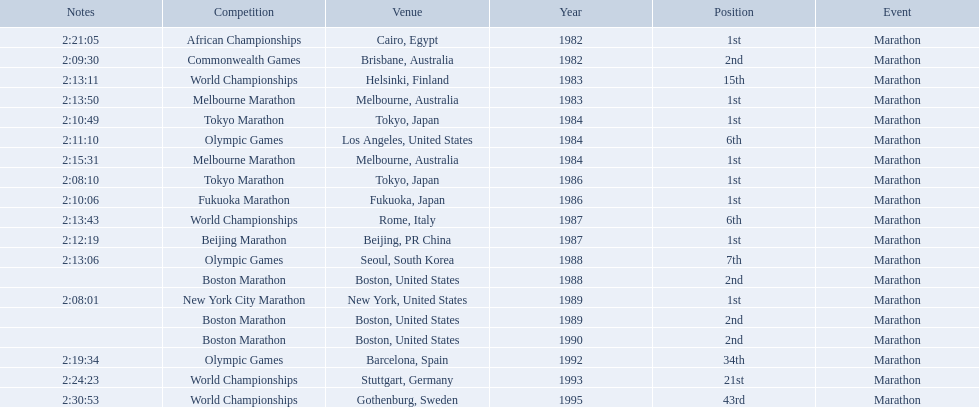What are all of the juma ikangaa competitions? African Championships, Commonwealth Games, World Championships, Melbourne Marathon, Tokyo Marathon, Olympic Games, Melbourne Marathon, Tokyo Marathon, Fukuoka Marathon, World Championships, Beijing Marathon, Olympic Games, Boston Marathon, New York City Marathon, Boston Marathon, Boston Marathon, Olympic Games, World Championships, World Championships. Which of these competitions did not take place in the united states? African Championships, Commonwealth Games, World Championships, Melbourne Marathon, Tokyo Marathon, Melbourne Marathon, Tokyo Marathon, Fukuoka Marathon, World Championships, Beijing Marathon, Olympic Games, Olympic Games, World Championships, World Championships. Out of these, which of them took place in asia? Tokyo Marathon, Tokyo Marathon, Fukuoka Marathon, Beijing Marathon, Olympic Games. Which of the remaining competitions took place in china? Beijing Marathon. 